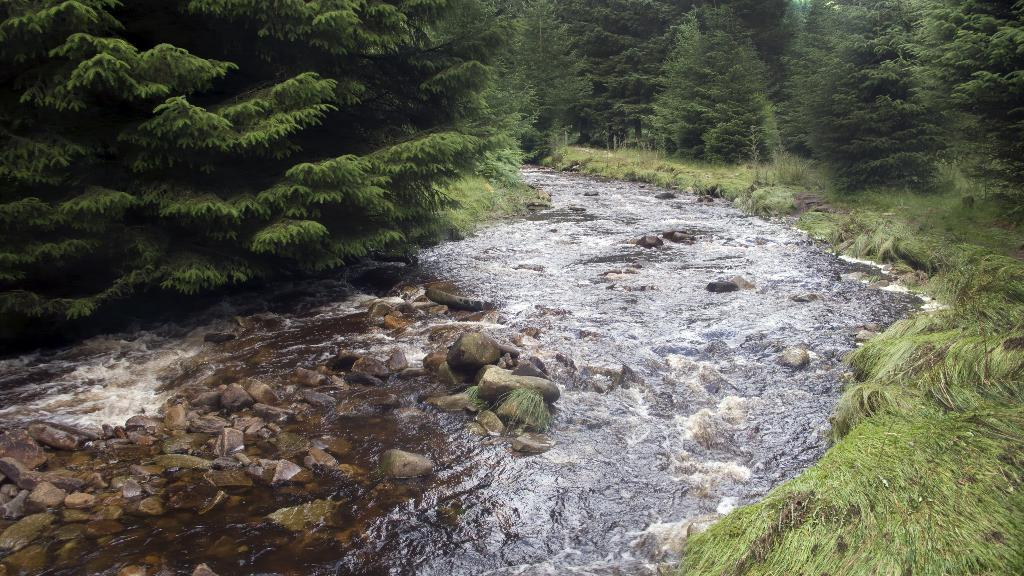What is the primary element present in the image? There is water in the image. What other objects or features can be seen in the image? There are stones, trees, and grass in the image. What year is depicted in the image? The image does not depict a specific year; it is a photograph of a natural scene. 